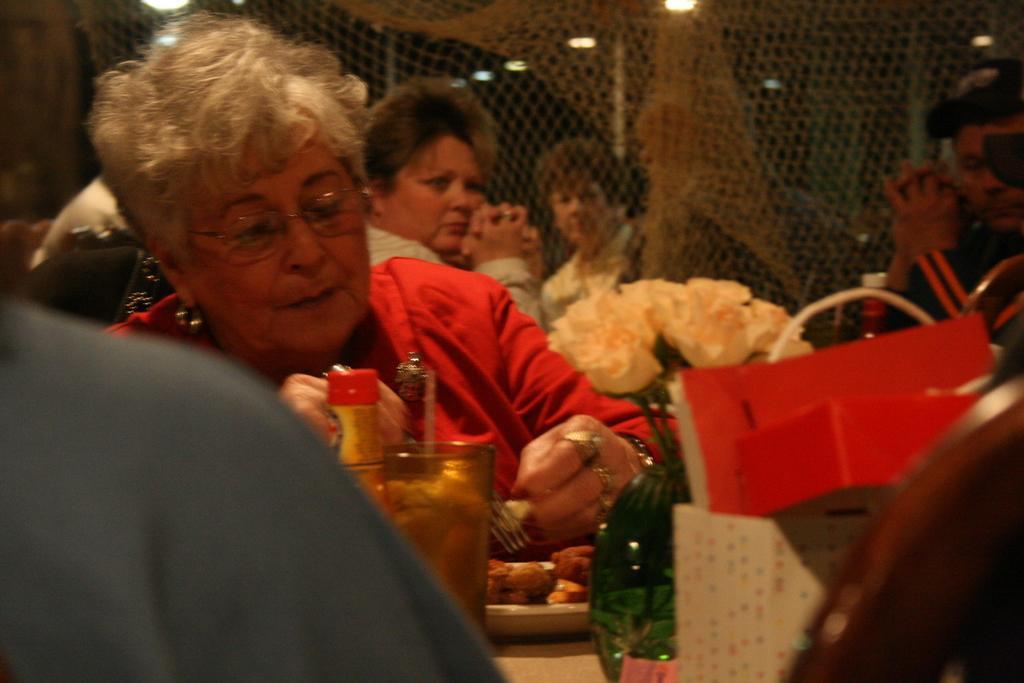How would you summarize this image in a sentence or two? This picture is taken inside the room. In this image, we can see a group of people sitting on the chair in front of the table, on the table, we can see a plate with some food, glass, flower pot, flowers and a bag. In the background, we can also see a net fence, outside the fence, we can also see a person. At the top, we can see a roof with few lights. 